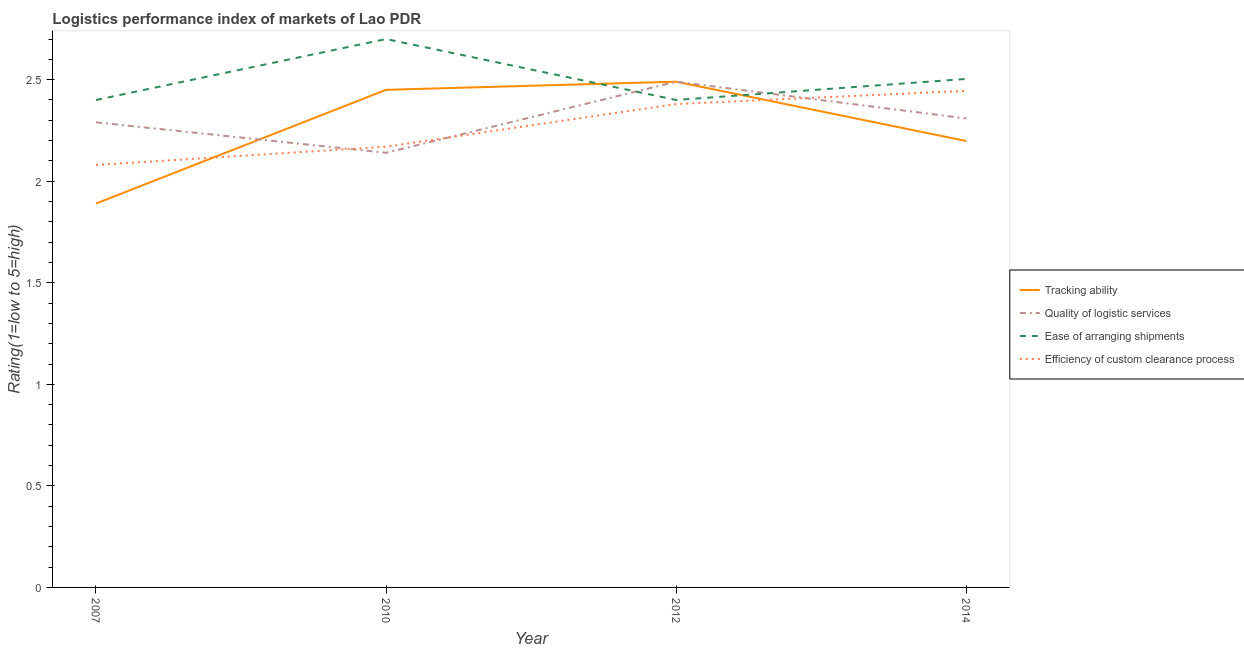What is the lpi rating of efficiency of custom clearance process in 2007?
Your response must be concise. 2.08. Across all years, what is the maximum lpi rating of efficiency of custom clearance process?
Ensure brevity in your answer.  2.45. Across all years, what is the minimum lpi rating of efficiency of custom clearance process?
Provide a short and direct response. 2.08. In which year was the lpi rating of efficiency of custom clearance process maximum?
Offer a terse response. 2014. In which year was the lpi rating of quality of logistic services minimum?
Your answer should be compact. 2010. What is the total lpi rating of tracking ability in the graph?
Provide a succinct answer. 9.03. What is the difference between the lpi rating of tracking ability in 2007 and that in 2012?
Keep it short and to the point. -0.6. What is the difference between the lpi rating of quality of logistic services in 2012 and the lpi rating of tracking ability in 2010?
Offer a very short reply. 0.04. What is the average lpi rating of efficiency of custom clearance process per year?
Your answer should be very brief. 2.27. In the year 2014, what is the difference between the lpi rating of tracking ability and lpi rating of ease of arranging shipments?
Provide a short and direct response. -0.31. What is the ratio of the lpi rating of ease of arranging shipments in 2010 to that in 2014?
Offer a very short reply. 1.08. Is the lpi rating of efficiency of custom clearance process in 2010 less than that in 2012?
Provide a succinct answer. Yes. Is the difference between the lpi rating of tracking ability in 2007 and 2012 greater than the difference between the lpi rating of efficiency of custom clearance process in 2007 and 2012?
Offer a very short reply. No. What is the difference between the highest and the second highest lpi rating of tracking ability?
Offer a terse response. 0.04. What is the difference between the highest and the lowest lpi rating of tracking ability?
Give a very brief answer. 0.6. Is the sum of the lpi rating of efficiency of custom clearance process in 2010 and 2014 greater than the maximum lpi rating of ease of arranging shipments across all years?
Offer a terse response. Yes. Is it the case that in every year, the sum of the lpi rating of tracking ability and lpi rating of quality of logistic services is greater than the lpi rating of ease of arranging shipments?
Offer a very short reply. Yes. Is the lpi rating of quality of logistic services strictly less than the lpi rating of efficiency of custom clearance process over the years?
Keep it short and to the point. No. How many lines are there?
Offer a terse response. 4. Are the values on the major ticks of Y-axis written in scientific E-notation?
Your answer should be very brief. No. Where does the legend appear in the graph?
Your response must be concise. Center right. How are the legend labels stacked?
Keep it short and to the point. Vertical. What is the title of the graph?
Your answer should be compact. Logistics performance index of markets of Lao PDR. What is the label or title of the Y-axis?
Offer a terse response. Rating(1=low to 5=high). What is the Rating(1=low to 5=high) of Tracking ability in 2007?
Offer a very short reply. 1.89. What is the Rating(1=low to 5=high) of Quality of logistic services in 2007?
Keep it short and to the point. 2.29. What is the Rating(1=low to 5=high) of Efficiency of custom clearance process in 2007?
Your response must be concise. 2.08. What is the Rating(1=low to 5=high) in Tracking ability in 2010?
Your response must be concise. 2.45. What is the Rating(1=low to 5=high) in Quality of logistic services in 2010?
Your response must be concise. 2.14. What is the Rating(1=low to 5=high) in Ease of arranging shipments in 2010?
Make the answer very short. 2.7. What is the Rating(1=low to 5=high) in Efficiency of custom clearance process in 2010?
Give a very brief answer. 2.17. What is the Rating(1=low to 5=high) in Tracking ability in 2012?
Give a very brief answer. 2.49. What is the Rating(1=low to 5=high) in Quality of logistic services in 2012?
Keep it short and to the point. 2.49. What is the Rating(1=low to 5=high) in Ease of arranging shipments in 2012?
Offer a terse response. 2.4. What is the Rating(1=low to 5=high) of Efficiency of custom clearance process in 2012?
Make the answer very short. 2.38. What is the Rating(1=low to 5=high) in Tracking ability in 2014?
Your response must be concise. 2.2. What is the Rating(1=low to 5=high) in Quality of logistic services in 2014?
Offer a very short reply. 2.31. What is the Rating(1=low to 5=high) of Ease of arranging shipments in 2014?
Offer a terse response. 2.5. What is the Rating(1=low to 5=high) in Efficiency of custom clearance process in 2014?
Provide a succinct answer. 2.45. Across all years, what is the maximum Rating(1=low to 5=high) of Tracking ability?
Your response must be concise. 2.49. Across all years, what is the maximum Rating(1=low to 5=high) of Quality of logistic services?
Make the answer very short. 2.49. Across all years, what is the maximum Rating(1=low to 5=high) of Ease of arranging shipments?
Your answer should be very brief. 2.7. Across all years, what is the maximum Rating(1=low to 5=high) of Efficiency of custom clearance process?
Make the answer very short. 2.45. Across all years, what is the minimum Rating(1=low to 5=high) in Tracking ability?
Provide a short and direct response. 1.89. Across all years, what is the minimum Rating(1=low to 5=high) of Quality of logistic services?
Give a very brief answer. 2.14. Across all years, what is the minimum Rating(1=low to 5=high) in Ease of arranging shipments?
Your answer should be very brief. 2.4. Across all years, what is the minimum Rating(1=low to 5=high) of Efficiency of custom clearance process?
Your answer should be compact. 2.08. What is the total Rating(1=low to 5=high) in Tracking ability in the graph?
Your answer should be compact. 9.03. What is the total Rating(1=low to 5=high) in Quality of logistic services in the graph?
Provide a succinct answer. 9.23. What is the total Rating(1=low to 5=high) in Ease of arranging shipments in the graph?
Your answer should be very brief. 10. What is the total Rating(1=low to 5=high) in Efficiency of custom clearance process in the graph?
Your response must be concise. 9.08. What is the difference between the Rating(1=low to 5=high) in Tracking ability in 2007 and that in 2010?
Offer a very short reply. -0.56. What is the difference between the Rating(1=low to 5=high) in Efficiency of custom clearance process in 2007 and that in 2010?
Give a very brief answer. -0.09. What is the difference between the Rating(1=low to 5=high) of Tracking ability in 2007 and that in 2012?
Your answer should be compact. -0.6. What is the difference between the Rating(1=low to 5=high) of Tracking ability in 2007 and that in 2014?
Your answer should be very brief. -0.31. What is the difference between the Rating(1=low to 5=high) of Quality of logistic services in 2007 and that in 2014?
Your answer should be compact. -0.02. What is the difference between the Rating(1=low to 5=high) in Ease of arranging shipments in 2007 and that in 2014?
Your response must be concise. -0.1. What is the difference between the Rating(1=low to 5=high) in Efficiency of custom clearance process in 2007 and that in 2014?
Offer a very short reply. -0.37. What is the difference between the Rating(1=low to 5=high) of Tracking ability in 2010 and that in 2012?
Your response must be concise. -0.04. What is the difference between the Rating(1=low to 5=high) in Quality of logistic services in 2010 and that in 2012?
Your answer should be very brief. -0.35. What is the difference between the Rating(1=low to 5=high) of Efficiency of custom clearance process in 2010 and that in 2012?
Offer a terse response. -0.21. What is the difference between the Rating(1=low to 5=high) of Tracking ability in 2010 and that in 2014?
Give a very brief answer. 0.25. What is the difference between the Rating(1=low to 5=high) of Quality of logistic services in 2010 and that in 2014?
Ensure brevity in your answer.  -0.17. What is the difference between the Rating(1=low to 5=high) in Ease of arranging shipments in 2010 and that in 2014?
Give a very brief answer. 0.2. What is the difference between the Rating(1=low to 5=high) of Efficiency of custom clearance process in 2010 and that in 2014?
Your answer should be compact. -0.28. What is the difference between the Rating(1=low to 5=high) in Tracking ability in 2012 and that in 2014?
Your answer should be compact. 0.29. What is the difference between the Rating(1=low to 5=high) of Quality of logistic services in 2012 and that in 2014?
Your answer should be compact. 0.18. What is the difference between the Rating(1=low to 5=high) in Ease of arranging shipments in 2012 and that in 2014?
Your answer should be very brief. -0.1. What is the difference between the Rating(1=low to 5=high) of Efficiency of custom clearance process in 2012 and that in 2014?
Provide a succinct answer. -0.07. What is the difference between the Rating(1=low to 5=high) of Tracking ability in 2007 and the Rating(1=low to 5=high) of Ease of arranging shipments in 2010?
Keep it short and to the point. -0.81. What is the difference between the Rating(1=low to 5=high) in Tracking ability in 2007 and the Rating(1=low to 5=high) in Efficiency of custom clearance process in 2010?
Ensure brevity in your answer.  -0.28. What is the difference between the Rating(1=low to 5=high) of Quality of logistic services in 2007 and the Rating(1=low to 5=high) of Ease of arranging shipments in 2010?
Provide a short and direct response. -0.41. What is the difference between the Rating(1=low to 5=high) of Quality of logistic services in 2007 and the Rating(1=low to 5=high) of Efficiency of custom clearance process in 2010?
Give a very brief answer. 0.12. What is the difference between the Rating(1=low to 5=high) of Ease of arranging shipments in 2007 and the Rating(1=low to 5=high) of Efficiency of custom clearance process in 2010?
Keep it short and to the point. 0.23. What is the difference between the Rating(1=low to 5=high) of Tracking ability in 2007 and the Rating(1=low to 5=high) of Quality of logistic services in 2012?
Make the answer very short. -0.6. What is the difference between the Rating(1=low to 5=high) in Tracking ability in 2007 and the Rating(1=low to 5=high) in Ease of arranging shipments in 2012?
Your answer should be very brief. -0.51. What is the difference between the Rating(1=low to 5=high) of Tracking ability in 2007 and the Rating(1=low to 5=high) of Efficiency of custom clearance process in 2012?
Keep it short and to the point. -0.49. What is the difference between the Rating(1=low to 5=high) of Quality of logistic services in 2007 and the Rating(1=low to 5=high) of Ease of arranging shipments in 2012?
Provide a succinct answer. -0.11. What is the difference between the Rating(1=low to 5=high) of Quality of logistic services in 2007 and the Rating(1=low to 5=high) of Efficiency of custom clearance process in 2012?
Your response must be concise. -0.09. What is the difference between the Rating(1=low to 5=high) in Ease of arranging shipments in 2007 and the Rating(1=low to 5=high) in Efficiency of custom clearance process in 2012?
Make the answer very short. 0.02. What is the difference between the Rating(1=low to 5=high) of Tracking ability in 2007 and the Rating(1=low to 5=high) of Quality of logistic services in 2014?
Provide a succinct answer. -0.42. What is the difference between the Rating(1=low to 5=high) in Tracking ability in 2007 and the Rating(1=low to 5=high) in Ease of arranging shipments in 2014?
Your answer should be compact. -0.61. What is the difference between the Rating(1=low to 5=high) of Tracking ability in 2007 and the Rating(1=low to 5=high) of Efficiency of custom clearance process in 2014?
Provide a succinct answer. -0.56. What is the difference between the Rating(1=low to 5=high) of Quality of logistic services in 2007 and the Rating(1=low to 5=high) of Ease of arranging shipments in 2014?
Keep it short and to the point. -0.21. What is the difference between the Rating(1=low to 5=high) in Quality of logistic services in 2007 and the Rating(1=low to 5=high) in Efficiency of custom clearance process in 2014?
Give a very brief answer. -0.16. What is the difference between the Rating(1=low to 5=high) in Ease of arranging shipments in 2007 and the Rating(1=low to 5=high) in Efficiency of custom clearance process in 2014?
Provide a succinct answer. -0.05. What is the difference between the Rating(1=low to 5=high) of Tracking ability in 2010 and the Rating(1=low to 5=high) of Quality of logistic services in 2012?
Ensure brevity in your answer.  -0.04. What is the difference between the Rating(1=low to 5=high) in Tracking ability in 2010 and the Rating(1=low to 5=high) in Efficiency of custom clearance process in 2012?
Give a very brief answer. 0.07. What is the difference between the Rating(1=low to 5=high) of Quality of logistic services in 2010 and the Rating(1=low to 5=high) of Ease of arranging shipments in 2012?
Your answer should be very brief. -0.26. What is the difference between the Rating(1=low to 5=high) of Quality of logistic services in 2010 and the Rating(1=low to 5=high) of Efficiency of custom clearance process in 2012?
Your answer should be compact. -0.24. What is the difference between the Rating(1=low to 5=high) of Ease of arranging shipments in 2010 and the Rating(1=low to 5=high) of Efficiency of custom clearance process in 2012?
Your answer should be compact. 0.32. What is the difference between the Rating(1=low to 5=high) of Tracking ability in 2010 and the Rating(1=low to 5=high) of Quality of logistic services in 2014?
Make the answer very short. 0.14. What is the difference between the Rating(1=low to 5=high) in Tracking ability in 2010 and the Rating(1=low to 5=high) in Ease of arranging shipments in 2014?
Your response must be concise. -0.05. What is the difference between the Rating(1=low to 5=high) in Tracking ability in 2010 and the Rating(1=low to 5=high) in Efficiency of custom clearance process in 2014?
Your response must be concise. 0. What is the difference between the Rating(1=low to 5=high) of Quality of logistic services in 2010 and the Rating(1=low to 5=high) of Ease of arranging shipments in 2014?
Your response must be concise. -0.36. What is the difference between the Rating(1=low to 5=high) in Quality of logistic services in 2010 and the Rating(1=low to 5=high) in Efficiency of custom clearance process in 2014?
Give a very brief answer. -0.31. What is the difference between the Rating(1=low to 5=high) in Ease of arranging shipments in 2010 and the Rating(1=low to 5=high) in Efficiency of custom clearance process in 2014?
Give a very brief answer. 0.25. What is the difference between the Rating(1=low to 5=high) in Tracking ability in 2012 and the Rating(1=low to 5=high) in Quality of logistic services in 2014?
Provide a short and direct response. 0.18. What is the difference between the Rating(1=low to 5=high) in Tracking ability in 2012 and the Rating(1=low to 5=high) in Ease of arranging shipments in 2014?
Your response must be concise. -0.01. What is the difference between the Rating(1=low to 5=high) in Tracking ability in 2012 and the Rating(1=low to 5=high) in Efficiency of custom clearance process in 2014?
Make the answer very short. 0.04. What is the difference between the Rating(1=low to 5=high) of Quality of logistic services in 2012 and the Rating(1=low to 5=high) of Ease of arranging shipments in 2014?
Ensure brevity in your answer.  -0.01. What is the difference between the Rating(1=low to 5=high) of Quality of logistic services in 2012 and the Rating(1=low to 5=high) of Efficiency of custom clearance process in 2014?
Offer a very short reply. 0.04. What is the difference between the Rating(1=low to 5=high) of Ease of arranging shipments in 2012 and the Rating(1=low to 5=high) of Efficiency of custom clearance process in 2014?
Offer a terse response. -0.05. What is the average Rating(1=low to 5=high) in Tracking ability per year?
Offer a very short reply. 2.26. What is the average Rating(1=low to 5=high) in Quality of logistic services per year?
Give a very brief answer. 2.31. What is the average Rating(1=low to 5=high) of Ease of arranging shipments per year?
Ensure brevity in your answer.  2.5. What is the average Rating(1=low to 5=high) of Efficiency of custom clearance process per year?
Keep it short and to the point. 2.27. In the year 2007, what is the difference between the Rating(1=low to 5=high) of Tracking ability and Rating(1=low to 5=high) of Ease of arranging shipments?
Ensure brevity in your answer.  -0.51. In the year 2007, what is the difference between the Rating(1=low to 5=high) in Tracking ability and Rating(1=low to 5=high) in Efficiency of custom clearance process?
Ensure brevity in your answer.  -0.19. In the year 2007, what is the difference between the Rating(1=low to 5=high) in Quality of logistic services and Rating(1=low to 5=high) in Ease of arranging shipments?
Offer a terse response. -0.11. In the year 2007, what is the difference between the Rating(1=low to 5=high) of Quality of logistic services and Rating(1=low to 5=high) of Efficiency of custom clearance process?
Offer a very short reply. 0.21. In the year 2007, what is the difference between the Rating(1=low to 5=high) in Ease of arranging shipments and Rating(1=low to 5=high) in Efficiency of custom clearance process?
Offer a very short reply. 0.32. In the year 2010, what is the difference between the Rating(1=low to 5=high) in Tracking ability and Rating(1=low to 5=high) in Quality of logistic services?
Give a very brief answer. 0.31. In the year 2010, what is the difference between the Rating(1=low to 5=high) in Tracking ability and Rating(1=low to 5=high) in Efficiency of custom clearance process?
Give a very brief answer. 0.28. In the year 2010, what is the difference between the Rating(1=low to 5=high) of Quality of logistic services and Rating(1=low to 5=high) of Ease of arranging shipments?
Offer a very short reply. -0.56. In the year 2010, what is the difference between the Rating(1=low to 5=high) of Quality of logistic services and Rating(1=low to 5=high) of Efficiency of custom clearance process?
Offer a terse response. -0.03. In the year 2010, what is the difference between the Rating(1=low to 5=high) of Ease of arranging shipments and Rating(1=low to 5=high) of Efficiency of custom clearance process?
Keep it short and to the point. 0.53. In the year 2012, what is the difference between the Rating(1=low to 5=high) of Tracking ability and Rating(1=low to 5=high) of Quality of logistic services?
Give a very brief answer. 0. In the year 2012, what is the difference between the Rating(1=low to 5=high) in Tracking ability and Rating(1=low to 5=high) in Ease of arranging shipments?
Your answer should be very brief. 0.09. In the year 2012, what is the difference between the Rating(1=low to 5=high) of Tracking ability and Rating(1=low to 5=high) of Efficiency of custom clearance process?
Your answer should be very brief. 0.11. In the year 2012, what is the difference between the Rating(1=low to 5=high) of Quality of logistic services and Rating(1=low to 5=high) of Ease of arranging shipments?
Keep it short and to the point. 0.09. In the year 2012, what is the difference between the Rating(1=low to 5=high) of Quality of logistic services and Rating(1=low to 5=high) of Efficiency of custom clearance process?
Provide a succinct answer. 0.11. In the year 2012, what is the difference between the Rating(1=low to 5=high) of Ease of arranging shipments and Rating(1=low to 5=high) of Efficiency of custom clearance process?
Offer a terse response. 0.02. In the year 2014, what is the difference between the Rating(1=low to 5=high) of Tracking ability and Rating(1=low to 5=high) of Quality of logistic services?
Make the answer very short. -0.11. In the year 2014, what is the difference between the Rating(1=low to 5=high) in Tracking ability and Rating(1=low to 5=high) in Ease of arranging shipments?
Your answer should be compact. -0.31. In the year 2014, what is the difference between the Rating(1=low to 5=high) in Tracking ability and Rating(1=low to 5=high) in Efficiency of custom clearance process?
Give a very brief answer. -0.25. In the year 2014, what is the difference between the Rating(1=low to 5=high) in Quality of logistic services and Rating(1=low to 5=high) in Ease of arranging shipments?
Your answer should be compact. -0.19. In the year 2014, what is the difference between the Rating(1=low to 5=high) of Quality of logistic services and Rating(1=low to 5=high) of Efficiency of custom clearance process?
Keep it short and to the point. -0.14. In the year 2014, what is the difference between the Rating(1=low to 5=high) of Ease of arranging shipments and Rating(1=low to 5=high) of Efficiency of custom clearance process?
Provide a succinct answer. 0.06. What is the ratio of the Rating(1=low to 5=high) of Tracking ability in 2007 to that in 2010?
Keep it short and to the point. 0.77. What is the ratio of the Rating(1=low to 5=high) in Quality of logistic services in 2007 to that in 2010?
Offer a very short reply. 1.07. What is the ratio of the Rating(1=low to 5=high) in Efficiency of custom clearance process in 2007 to that in 2010?
Your response must be concise. 0.96. What is the ratio of the Rating(1=low to 5=high) in Tracking ability in 2007 to that in 2012?
Ensure brevity in your answer.  0.76. What is the ratio of the Rating(1=low to 5=high) in Quality of logistic services in 2007 to that in 2012?
Provide a succinct answer. 0.92. What is the ratio of the Rating(1=low to 5=high) in Efficiency of custom clearance process in 2007 to that in 2012?
Your response must be concise. 0.87. What is the ratio of the Rating(1=low to 5=high) in Tracking ability in 2007 to that in 2014?
Offer a very short reply. 0.86. What is the ratio of the Rating(1=low to 5=high) in Ease of arranging shipments in 2007 to that in 2014?
Ensure brevity in your answer.  0.96. What is the ratio of the Rating(1=low to 5=high) in Efficiency of custom clearance process in 2007 to that in 2014?
Ensure brevity in your answer.  0.85. What is the ratio of the Rating(1=low to 5=high) in Tracking ability in 2010 to that in 2012?
Offer a very short reply. 0.98. What is the ratio of the Rating(1=low to 5=high) of Quality of logistic services in 2010 to that in 2012?
Keep it short and to the point. 0.86. What is the ratio of the Rating(1=low to 5=high) in Efficiency of custom clearance process in 2010 to that in 2012?
Provide a short and direct response. 0.91. What is the ratio of the Rating(1=low to 5=high) in Tracking ability in 2010 to that in 2014?
Keep it short and to the point. 1.11. What is the ratio of the Rating(1=low to 5=high) of Quality of logistic services in 2010 to that in 2014?
Give a very brief answer. 0.93. What is the ratio of the Rating(1=low to 5=high) in Ease of arranging shipments in 2010 to that in 2014?
Give a very brief answer. 1.08. What is the ratio of the Rating(1=low to 5=high) of Efficiency of custom clearance process in 2010 to that in 2014?
Keep it short and to the point. 0.89. What is the ratio of the Rating(1=low to 5=high) of Tracking ability in 2012 to that in 2014?
Offer a terse response. 1.13. What is the ratio of the Rating(1=low to 5=high) of Quality of logistic services in 2012 to that in 2014?
Ensure brevity in your answer.  1.08. What is the ratio of the Rating(1=low to 5=high) in Ease of arranging shipments in 2012 to that in 2014?
Ensure brevity in your answer.  0.96. What is the ratio of the Rating(1=low to 5=high) in Efficiency of custom clearance process in 2012 to that in 2014?
Offer a very short reply. 0.97. What is the difference between the highest and the second highest Rating(1=low to 5=high) of Quality of logistic services?
Keep it short and to the point. 0.18. What is the difference between the highest and the second highest Rating(1=low to 5=high) of Ease of arranging shipments?
Your response must be concise. 0.2. What is the difference between the highest and the second highest Rating(1=low to 5=high) of Efficiency of custom clearance process?
Make the answer very short. 0.07. What is the difference between the highest and the lowest Rating(1=low to 5=high) in Tracking ability?
Your response must be concise. 0.6. What is the difference between the highest and the lowest Rating(1=low to 5=high) of Efficiency of custom clearance process?
Provide a succinct answer. 0.37. 